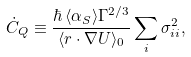Convert formula to latex. <formula><loc_0><loc_0><loc_500><loc_500>\dot { C } _ { Q } \equiv \frac { \hbar { \, } \langle \alpha _ { S } \rangle \Gamma ^ { 2 / 3 } } { \langle { r } \cdot \nabla U \rangle _ { 0 } } \sum _ { i } \sigma _ { i i } ^ { 2 } ,</formula> 